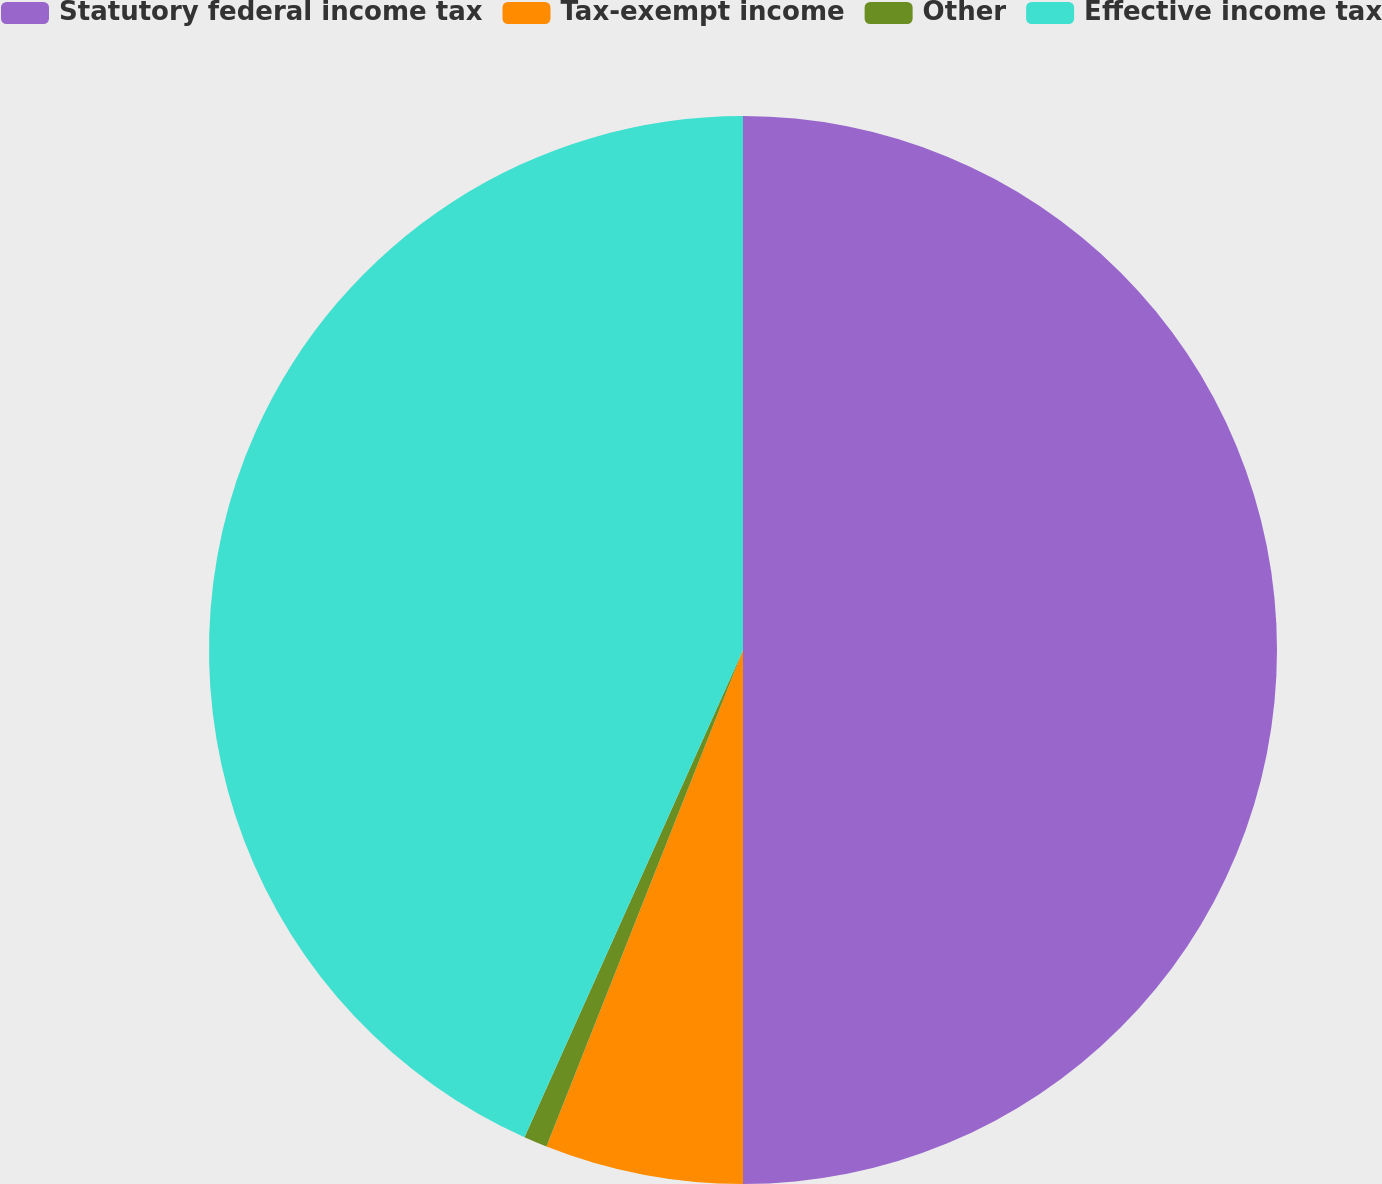<chart> <loc_0><loc_0><loc_500><loc_500><pie_chart><fcel>Statutory federal income tax<fcel>Tax-exempt income<fcel>Other<fcel>Effective income tax<nl><fcel>50.0%<fcel>6.0%<fcel>0.71%<fcel>43.29%<nl></chart> 